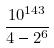<formula> <loc_0><loc_0><loc_500><loc_500>\frac { 1 0 ^ { 1 4 3 } } { 4 - 2 ^ { 6 } }</formula> 